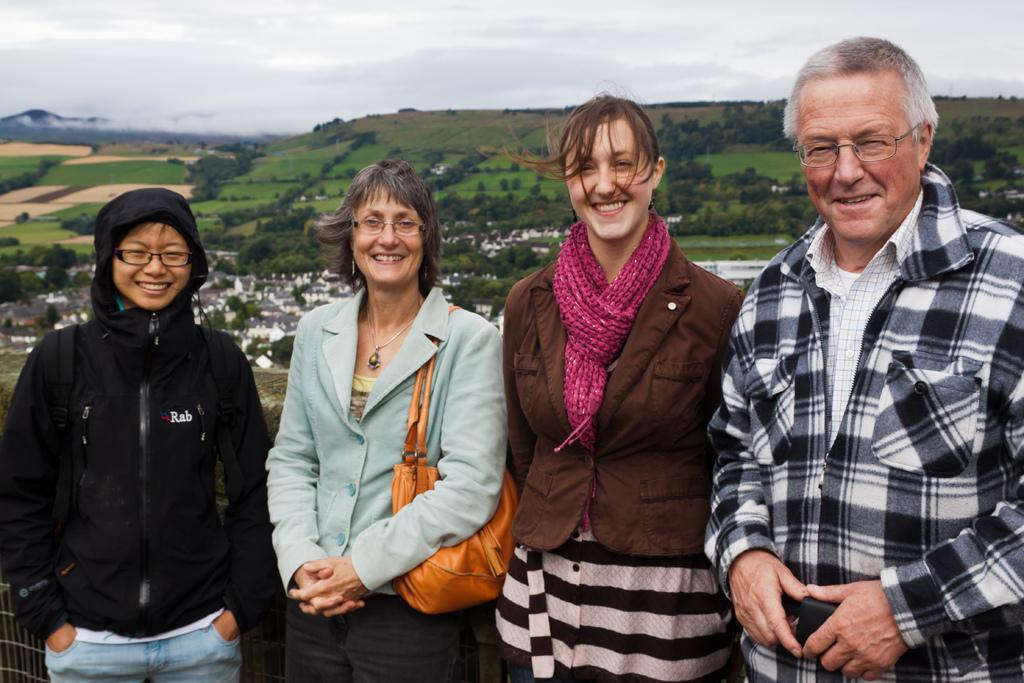How many people are present in the image? There are four people in the image. What expressions do the people have? The people are smiling in the image. What can be seen in the background of the image? There are houses, trees, and the sky visible in the background of the image. What type of bait is being used by the people in the image? There is no mention of fishing or bait in the image; the people are simply smiling. What direction are the people moving in the image? The image does not show any motion or movement of the people; they are standing still and smiling. 